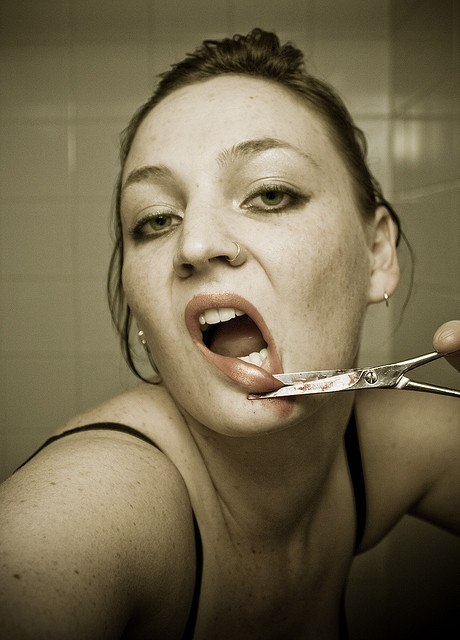Describe the objects in this image and their specific colors. I can see people in black, tan, and gray tones and scissors in black, white, olive, and gray tones in this image. 